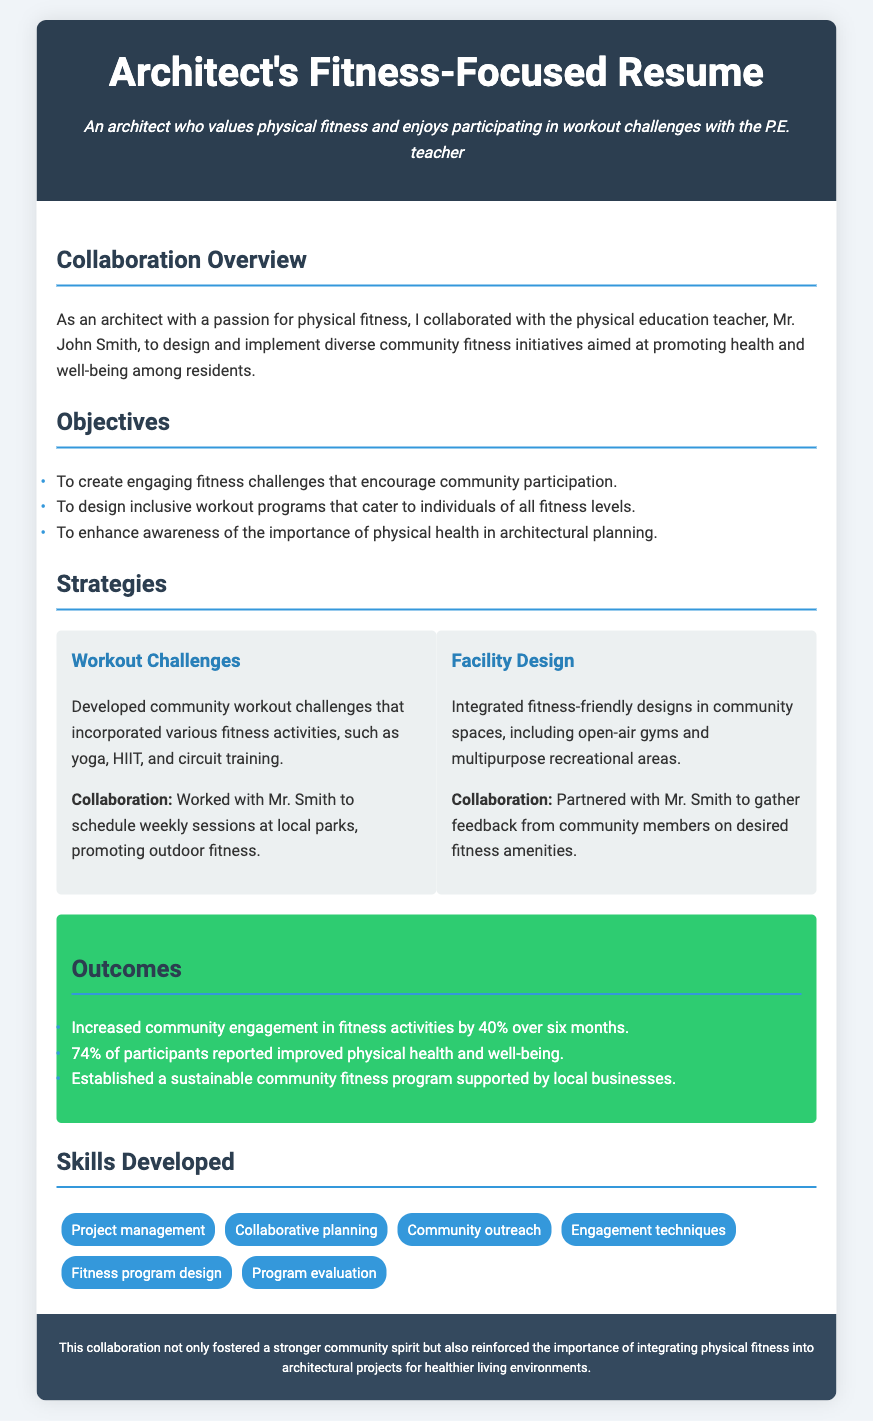What is the role of Mr. John Smith? Mr. John Smith is the physical education teacher who collaborated on fitness initiatives.
Answer: physical education teacher What percentage increase in community engagement was achieved? The document states that community engagement in fitness activities increased by 40% over six months.
Answer: 40% What are the two main strategies mentioned for the collaboration? The two strategies include developing workout challenges and integrating fitness-friendly designs.
Answer: Workout Challenges and Facility Design How many participants reported improved physical health? The document mentions that 74% of participants reported improved physical health and well-being.
Answer: 74% How long did the initiative take to achieve results? The increase in community engagement was measured over six months.
Answer: six months What skill involves gathering community feedback? The skill related to gathering feedback from community members is community outreach.
Answer: community outreach What is the main objective of the initiatives? The overarching goal is to promote health and well-being among residents.
Answer: promote health and well-being What type of spaces were proposed in the facility design? The initiative included open-air gyms and multipurpose recreational areas.
Answer: open-air gyms and multipurpose recreational areas Which section of the resume contains information about outcomes? The outcomes of the initiatives are discussed in the section titled "Outcomes."
Answer: Outcomes 